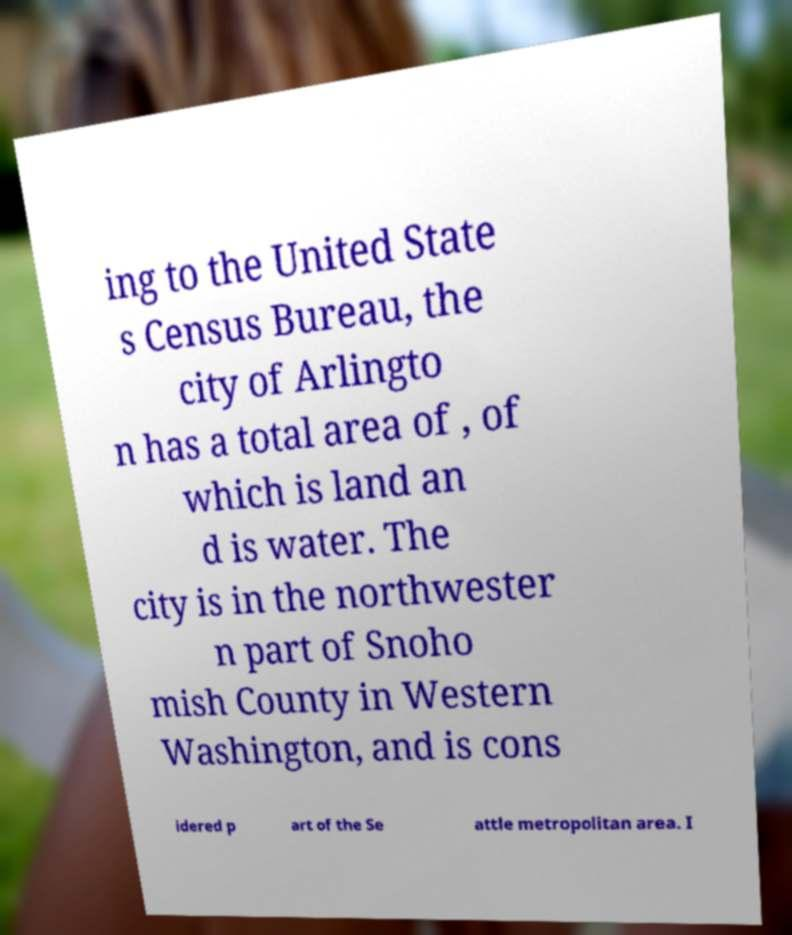Please read and relay the text visible in this image. What does it say? ing to the United State s Census Bureau, the city of Arlingto n has a total area of , of which is land an d is water. The city is in the northwester n part of Snoho mish County in Western Washington, and is cons idered p art of the Se attle metropolitan area. I 